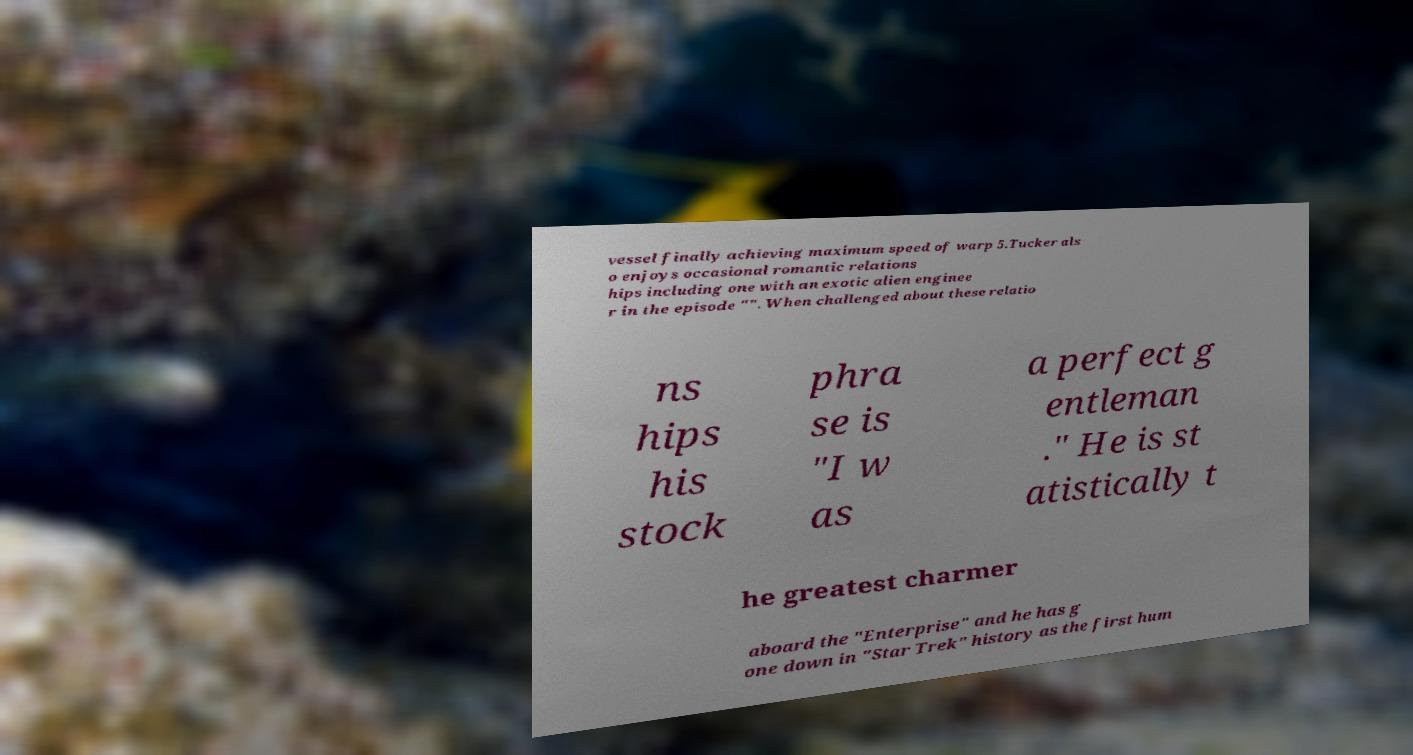Could you extract and type out the text from this image? vessel finally achieving maximum speed of warp 5.Tucker als o enjoys occasional romantic relations hips including one with an exotic alien enginee r in the episode "". When challenged about these relatio ns hips his stock phra se is "I w as a perfect g entleman ." He is st atistically t he greatest charmer aboard the "Enterprise" and he has g one down in "Star Trek" history as the first hum 